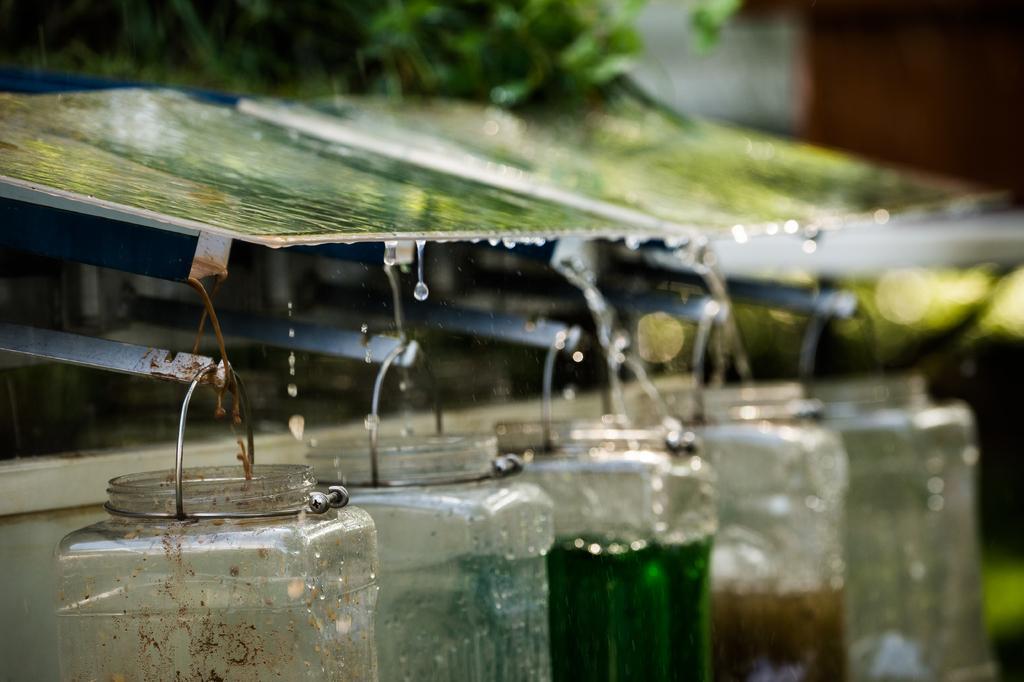Describe this image in one or two sentences. In the image there is a shelter and under that shelter there are some bottles hanged to the rods, the water from that shelter are being collected into the bottles. 